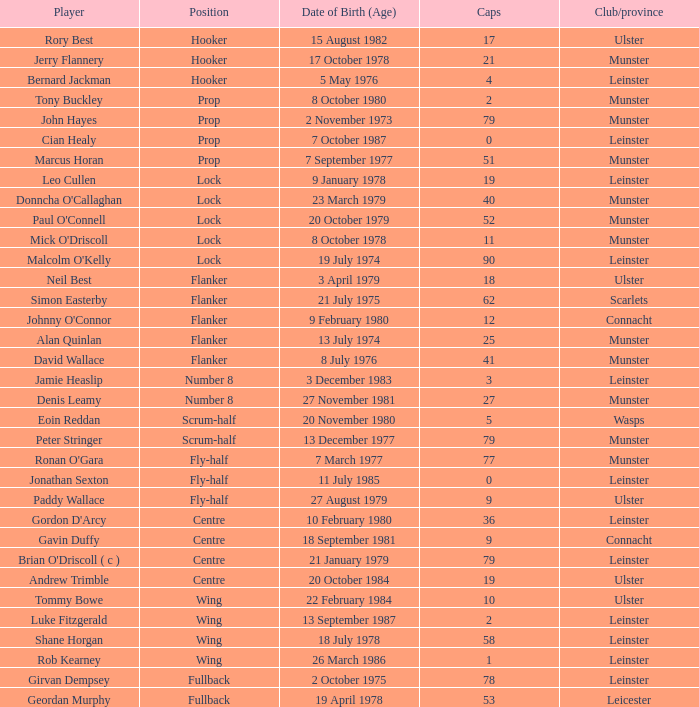What is the total number of caps for paddy wallace, a fly-half player? 9.0. 